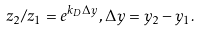<formula> <loc_0><loc_0><loc_500><loc_500>z _ { 2 } / z _ { 1 } = e ^ { k _ { D } \Delta y } , \Delta y = y _ { 2 } - y _ { 1 } .</formula> 